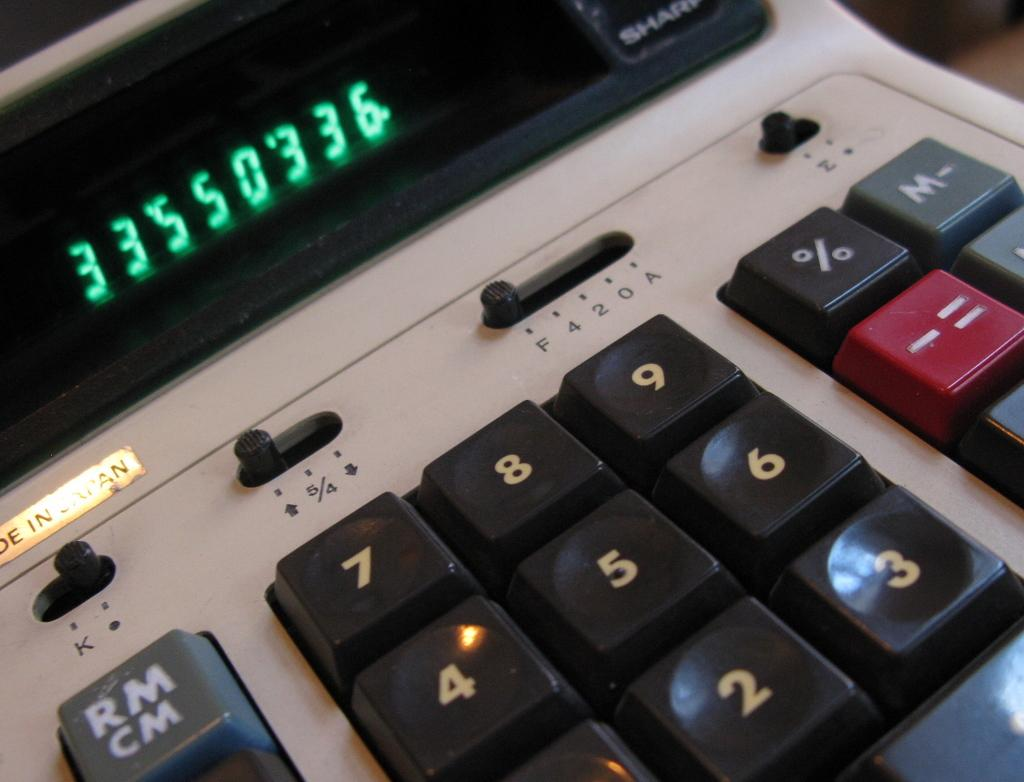<image>
Give a short and clear explanation of the subsequent image. Someone has typed the digits 33550336 on this calculator. 